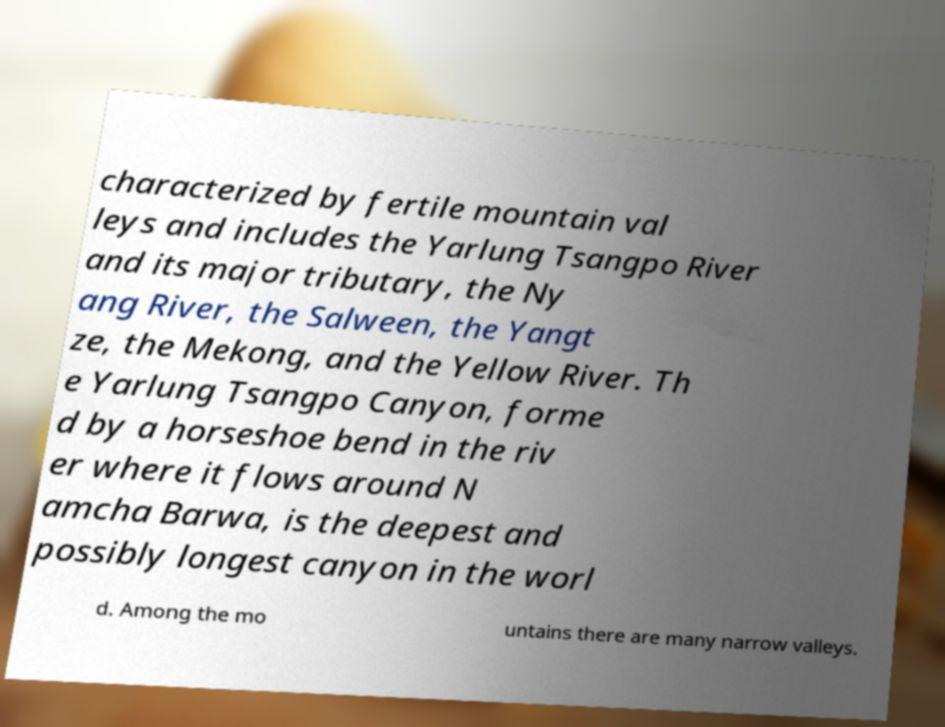Please identify and transcribe the text found in this image. characterized by fertile mountain val leys and includes the Yarlung Tsangpo River and its major tributary, the Ny ang River, the Salween, the Yangt ze, the Mekong, and the Yellow River. Th e Yarlung Tsangpo Canyon, forme d by a horseshoe bend in the riv er where it flows around N amcha Barwa, is the deepest and possibly longest canyon in the worl d. Among the mo untains there are many narrow valleys. 